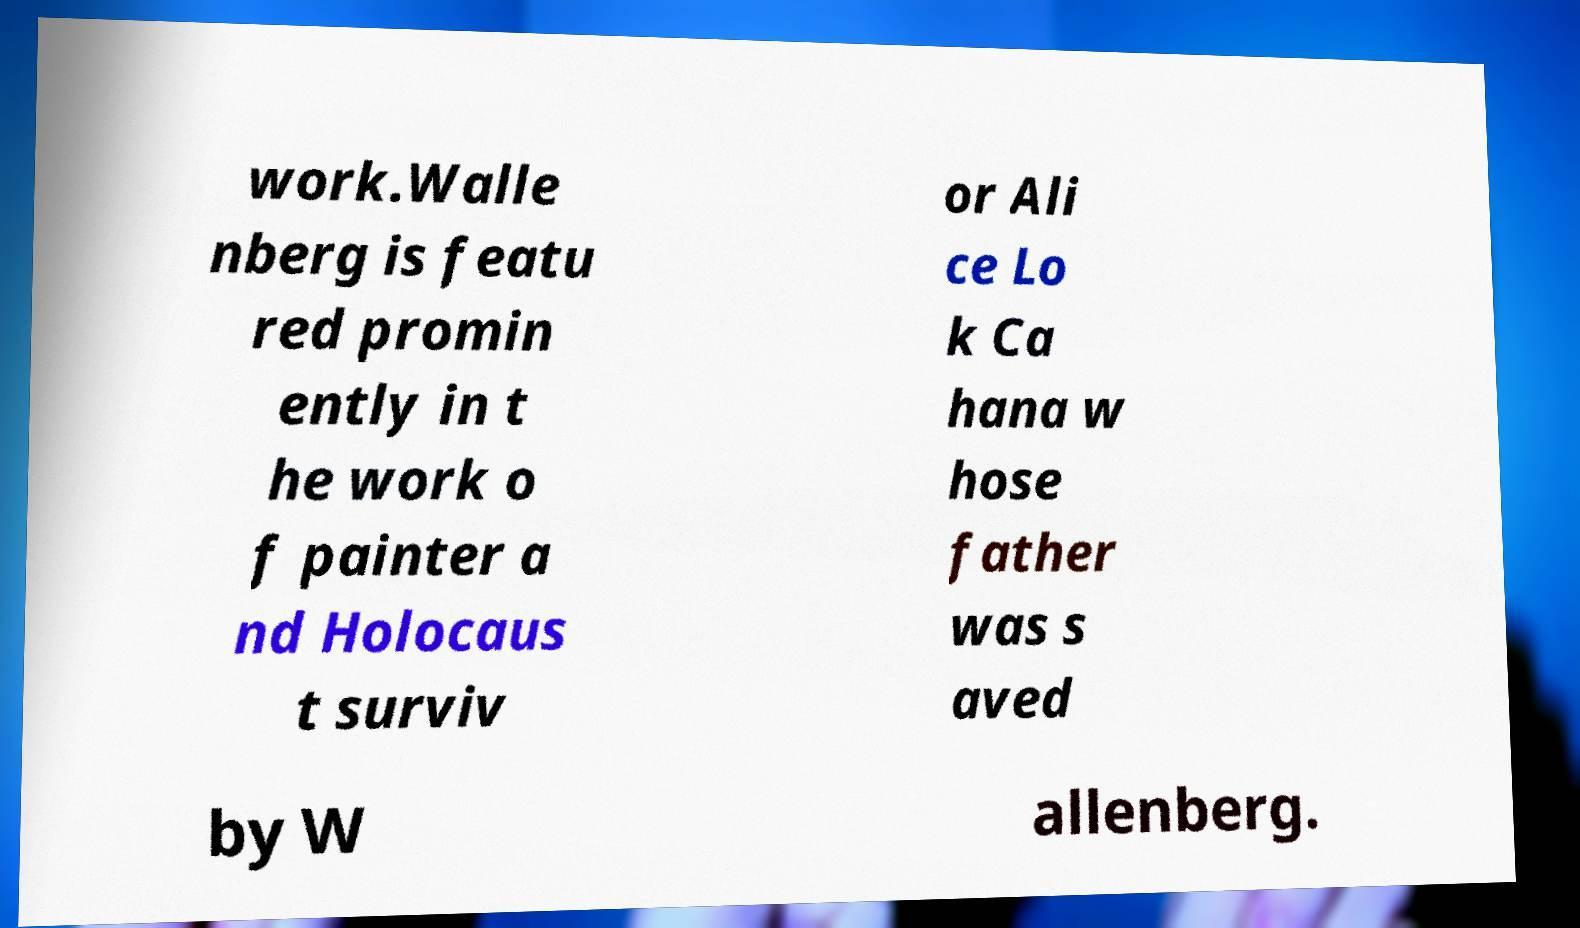I need the written content from this picture converted into text. Can you do that? work.Walle nberg is featu red promin ently in t he work o f painter a nd Holocaus t surviv or Ali ce Lo k Ca hana w hose father was s aved by W allenberg. 